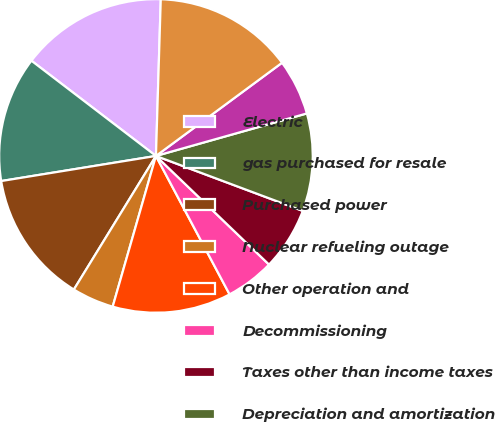<chart> <loc_0><loc_0><loc_500><loc_500><pie_chart><fcel>Electric<fcel>gas purchased for resale<fcel>Purchased power<fcel>Nuclear refueling outage<fcel>Other operation and<fcel>Decommissioning<fcel>Taxes other than income taxes<fcel>Depreciation and amortization<fcel>Other regulatory charges<fcel>TOTAL<nl><fcel>15.1%<fcel>12.95%<fcel>13.67%<fcel>4.32%<fcel>12.23%<fcel>5.04%<fcel>6.48%<fcel>10.07%<fcel>5.76%<fcel>14.38%<nl></chart> 